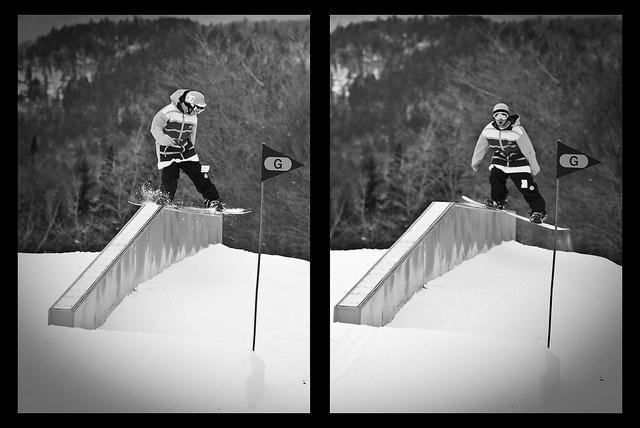How many people are there?
Give a very brief answer. 2. How many yellow buses are there?
Give a very brief answer. 0. 